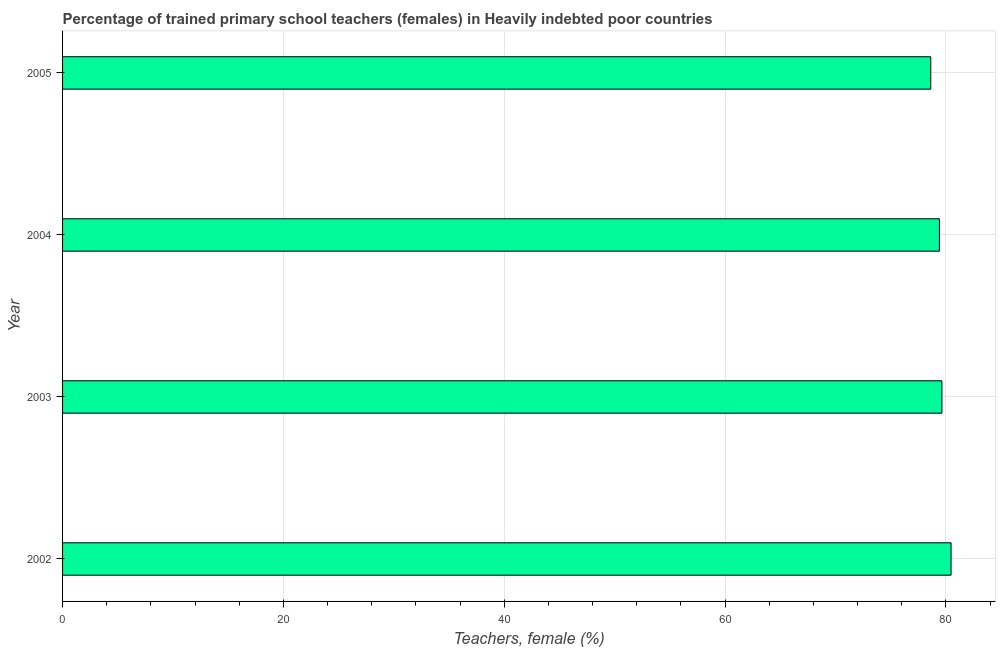Does the graph contain any zero values?
Offer a terse response. No. What is the title of the graph?
Provide a short and direct response. Percentage of trained primary school teachers (females) in Heavily indebted poor countries. What is the label or title of the X-axis?
Your response must be concise. Teachers, female (%). What is the label or title of the Y-axis?
Provide a succinct answer. Year. What is the percentage of trained female teachers in 2004?
Give a very brief answer. 79.42. Across all years, what is the maximum percentage of trained female teachers?
Provide a short and direct response. 80.47. Across all years, what is the minimum percentage of trained female teachers?
Your answer should be compact. 78.63. In which year was the percentage of trained female teachers minimum?
Give a very brief answer. 2005. What is the sum of the percentage of trained female teachers?
Your answer should be compact. 318.16. What is the difference between the percentage of trained female teachers in 2002 and 2003?
Keep it short and to the point. 0.83. What is the average percentage of trained female teachers per year?
Keep it short and to the point. 79.54. What is the median percentage of trained female teachers?
Offer a very short reply. 79.53. Is the percentage of trained female teachers in 2003 less than that in 2004?
Your answer should be compact. No. What is the difference between the highest and the second highest percentage of trained female teachers?
Give a very brief answer. 0.83. Is the sum of the percentage of trained female teachers in 2002 and 2003 greater than the maximum percentage of trained female teachers across all years?
Provide a short and direct response. Yes. What is the difference between the highest and the lowest percentage of trained female teachers?
Give a very brief answer. 1.84. In how many years, is the percentage of trained female teachers greater than the average percentage of trained female teachers taken over all years?
Ensure brevity in your answer.  2. How many bars are there?
Provide a short and direct response. 4. How many years are there in the graph?
Make the answer very short. 4. Are the values on the major ticks of X-axis written in scientific E-notation?
Keep it short and to the point. No. What is the Teachers, female (%) in 2002?
Keep it short and to the point. 80.47. What is the Teachers, female (%) of 2003?
Offer a terse response. 79.64. What is the Teachers, female (%) in 2004?
Keep it short and to the point. 79.42. What is the Teachers, female (%) of 2005?
Your response must be concise. 78.63. What is the difference between the Teachers, female (%) in 2002 and 2003?
Make the answer very short. 0.83. What is the difference between the Teachers, female (%) in 2002 and 2004?
Give a very brief answer. 1.05. What is the difference between the Teachers, female (%) in 2002 and 2005?
Keep it short and to the point. 1.84. What is the difference between the Teachers, female (%) in 2003 and 2004?
Provide a succinct answer. 0.23. What is the difference between the Teachers, female (%) in 2003 and 2005?
Your answer should be compact. 1.01. What is the difference between the Teachers, female (%) in 2004 and 2005?
Ensure brevity in your answer.  0.78. What is the ratio of the Teachers, female (%) in 2002 to that in 2005?
Provide a succinct answer. 1.02. What is the ratio of the Teachers, female (%) in 2003 to that in 2004?
Provide a short and direct response. 1. What is the ratio of the Teachers, female (%) in 2003 to that in 2005?
Keep it short and to the point. 1.01. 